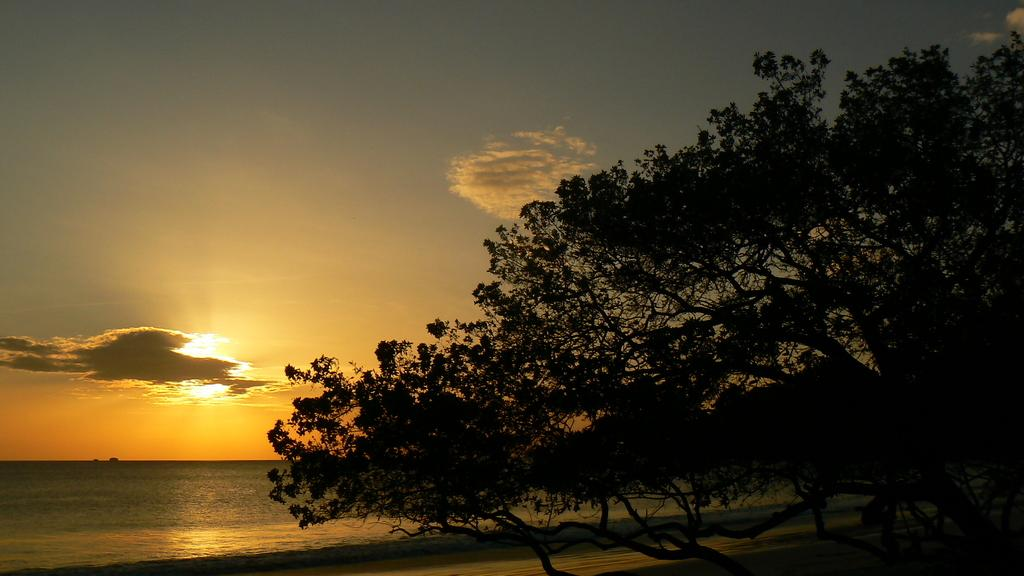What type of vegetation can be seen in the image? There are trees in the image. What natural element is visible in the image? There is water visible in the image. How is the sun depicted in the image? The sun is behind clouds in the image. What is the color of the sky in the background? The sky in the background is dark. Can you see any men reading books in the image? There are no men or books present in the image. What type of sponge is floating on the water in the image? There is no sponge visible in the image; it only features trees, water, and a dark sky. 